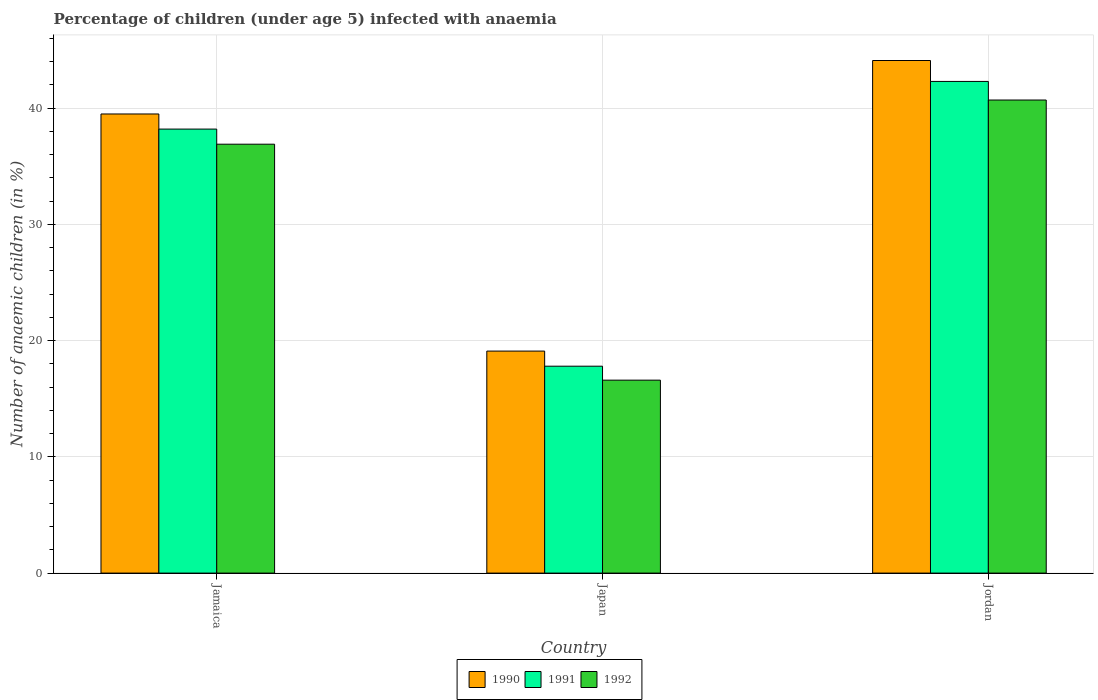How many different coloured bars are there?
Keep it short and to the point. 3. How many groups of bars are there?
Make the answer very short. 3. What is the label of the 3rd group of bars from the left?
Your answer should be compact. Jordan. In how many cases, is the number of bars for a given country not equal to the number of legend labels?
Make the answer very short. 0. What is the percentage of children infected with anaemia in in 1990 in Jamaica?
Give a very brief answer. 39.5. Across all countries, what is the maximum percentage of children infected with anaemia in in 1991?
Make the answer very short. 42.3. Across all countries, what is the minimum percentage of children infected with anaemia in in 1991?
Your answer should be compact. 17.8. In which country was the percentage of children infected with anaemia in in 1991 maximum?
Your answer should be compact. Jordan. In which country was the percentage of children infected with anaemia in in 1990 minimum?
Make the answer very short. Japan. What is the total percentage of children infected with anaemia in in 1990 in the graph?
Offer a terse response. 102.7. What is the difference between the percentage of children infected with anaemia in in 1992 in Japan and that in Jordan?
Offer a terse response. -24.1. What is the average percentage of children infected with anaemia in in 1992 per country?
Your answer should be very brief. 31.4. What is the difference between the percentage of children infected with anaemia in of/in 1990 and percentage of children infected with anaemia in of/in 1991 in Jamaica?
Offer a very short reply. 1.3. In how many countries, is the percentage of children infected with anaemia in in 1992 greater than 12 %?
Provide a succinct answer. 3. What is the ratio of the percentage of children infected with anaemia in in 1991 in Jamaica to that in Japan?
Offer a terse response. 2.15. What is the difference between the highest and the second highest percentage of children infected with anaemia in in 1992?
Keep it short and to the point. 24.1. What is the difference between the highest and the lowest percentage of children infected with anaemia in in 1991?
Your answer should be compact. 24.5. Is the sum of the percentage of children infected with anaemia in in 1990 in Jamaica and Japan greater than the maximum percentage of children infected with anaemia in in 1991 across all countries?
Offer a terse response. Yes. What does the 3rd bar from the right in Japan represents?
Give a very brief answer. 1990. How many countries are there in the graph?
Make the answer very short. 3. What is the difference between two consecutive major ticks on the Y-axis?
Your answer should be very brief. 10. Does the graph contain any zero values?
Your response must be concise. No. How many legend labels are there?
Provide a short and direct response. 3. What is the title of the graph?
Offer a terse response. Percentage of children (under age 5) infected with anaemia. Does "1989" appear as one of the legend labels in the graph?
Your answer should be very brief. No. What is the label or title of the Y-axis?
Ensure brevity in your answer.  Number of anaemic children (in %). What is the Number of anaemic children (in %) of 1990 in Jamaica?
Offer a very short reply. 39.5. What is the Number of anaemic children (in %) of 1991 in Jamaica?
Your answer should be compact. 38.2. What is the Number of anaemic children (in %) in 1992 in Jamaica?
Your response must be concise. 36.9. What is the Number of anaemic children (in %) in 1990 in Japan?
Make the answer very short. 19.1. What is the Number of anaemic children (in %) in 1990 in Jordan?
Offer a very short reply. 44.1. What is the Number of anaemic children (in %) in 1991 in Jordan?
Offer a terse response. 42.3. What is the Number of anaemic children (in %) in 1992 in Jordan?
Your response must be concise. 40.7. Across all countries, what is the maximum Number of anaemic children (in %) of 1990?
Make the answer very short. 44.1. Across all countries, what is the maximum Number of anaemic children (in %) in 1991?
Ensure brevity in your answer.  42.3. Across all countries, what is the maximum Number of anaemic children (in %) in 1992?
Offer a very short reply. 40.7. Across all countries, what is the minimum Number of anaemic children (in %) in 1992?
Offer a very short reply. 16.6. What is the total Number of anaemic children (in %) in 1990 in the graph?
Provide a succinct answer. 102.7. What is the total Number of anaemic children (in %) in 1991 in the graph?
Offer a very short reply. 98.3. What is the total Number of anaemic children (in %) in 1992 in the graph?
Your response must be concise. 94.2. What is the difference between the Number of anaemic children (in %) in 1990 in Jamaica and that in Japan?
Your response must be concise. 20.4. What is the difference between the Number of anaemic children (in %) in 1991 in Jamaica and that in Japan?
Provide a succinct answer. 20.4. What is the difference between the Number of anaemic children (in %) in 1992 in Jamaica and that in Japan?
Keep it short and to the point. 20.3. What is the difference between the Number of anaemic children (in %) in 1990 in Japan and that in Jordan?
Ensure brevity in your answer.  -25. What is the difference between the Number of anaemic children (in %) of 1991 in Japan and that in Jordan?
Make the answer very short. -24.5. What is the difference between the Number of anaemic children (in %) in 1992 in Japan and that in Jordan?
Give a very brief answer. -24.1. What is the difference between the Number of anaemic children (in %) in 1990 in Jamaica and the Number of anaemic children (in %) in 1991 in Japan?
Give a very brief answer. 21.7. What is the difference between the Number of anaemic children (in %) in 1990 in Jamaica and the Number of anaemic children (in %) in 1992 in Japan?
Your answer should be very brief. 22.9. What is the difference between the Number of anaemic children (in %) in 1991 in Jamaica and the Number of anaemic children (in %) in 1992 in Japan?
Offer a very short reply. 21.6. What is the difference between the Number of anaemic children (in %) in 1991 in Jamaica and the Number of anaemic children (in %) in 1992 in Jordan?
Your response must be concise. -2.5. What is the difference between the Number of anaemic children (in %) in 1990 in Japan and the Number of anaemic children (in %) in 1991 in Jordan?
Provide a succinct answer. -23.2. What is the difference between the Number of anaemic children (in %) in 1990 in Japan and the Number of anaemic children (in %) in 1992 in Jordan?
Your response must be concise. -21.6. What is the difference between the Number of anaemic children (in %) in 1991 in Japan and the Number of anaemic children (in %) in 1992 in Jordan?
Your answer should be very brief. -22.9. What is the average Number of anaemic children (in %) in 1990 per country?
Provide a short and direct response. 34.23. What is the average Number of anaemic children (in %) of 1991 per country?
Provide a succinct answer. 32.77. What is the average Number of anaemic children (in %) of 1992 per country?
Your answer should be very brief. 31.4. What is the difference between the Number of anaemic children (in %) of 1991 and Number of anaemic children (in %) of 1992 in Jamaica?
Offer a terse response. 1.3. What is the difference between the Number of anaemic children (in %) in 1990 and Number of anaemic children (in %) in 1992 in Japan?
Make the answer very short. 2.5. What is the difference between the Number of anaemic children (in %) of 1991 and Number of anaemic children (in %) of 1992 in Japan?
Your response must be concise. 1.2. What is the difference between the Number of anaemic children (in %) of 1990 and Number of anaemic children (in %) of 1992 in Jordan?
Offer a terse response. 3.4. What is the difference between the Number of anaemic children (in %) of 1991 and Number of anaemic children (in %) of 1992 in Jordan?
Offer a terse response. 1.6. What is the ratio of the Number of anaemic children (in %) of 1990 in Jamaica to that in Japan?
Your answer should be very brief. 2.07. What is the ratio of the Number of anaemic children (in %) in 1991 in Jamaica to that in Japan?
Give a very brief answer. 2.15. What is the ratio of the Number of anaemic children (in %) of 1992 in Jamaica to that in Japan?
Offer a very short reply. 2.22. What is the ratio of the Number of anaemic children (in %) of 1990 in Jamaica to that in Jordan?
Provide a short and direct response. 0.9. What is the ratio of the Number of anaemic children (in %) of 1991 in Jamaica to that in Jordan?
Make the answer very short. 0.9. What is the ratio of the Number of anaemic children (in %) in 1992 in Jamaica to that in Jordan?
Give a very brief answer. 0.91. What is the ratio of the Number of anaemic children (in %) of 1990 in Japan to that in Jordan?
Make the answer very short. 0.43. What is the ratio of the Number of anaemic children (in %) in 1991 in Japan to that in Jordan?
Give a very brief answer. 0.42. What is the ratio of the Number of anaemic children (in %) in 1992 in Japan to that in Jordan?
Offer a terse response. 0.41. What is the difference between the highest and the second highest Number of anaemic children (in %) in 1990?
Provide a short and direct response. 4.6. What is the difference between the highest and the second highest Number of anaemic children (in %) in 1992?
Keep it short and to the point. 3.8. What is the difference between the highest and the lowest Number of anaemic children (in %) of 1990?
Give a very brief answer. 25. What is the difference between the highest and the lowest Number of anaemic children (in %) in 1992?
Offer a very short reply. 24.1. 